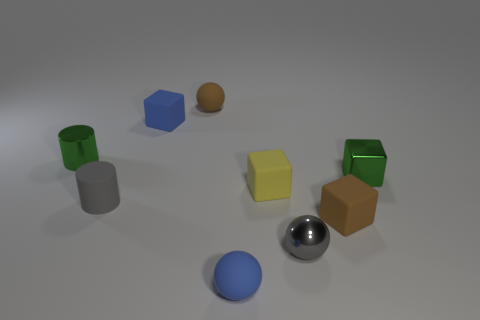Subtract 1 balls. How many balls are left? 2 Subtract all purple blocks. Subtract all blue cylinders. How many blocks are left? 4 Subtract all spheres. How many objects are left? 6 Subtract all tiny cylinders. Subtract all small gray matte things. How many objects are left? 6 Add 7 small blue rubber blocks. How many small blue rubber blocks are left? 8 Add 1 large blue things. How many large blue things exist? 1 Subtract 1 brown balls. How many objects are left? 8 